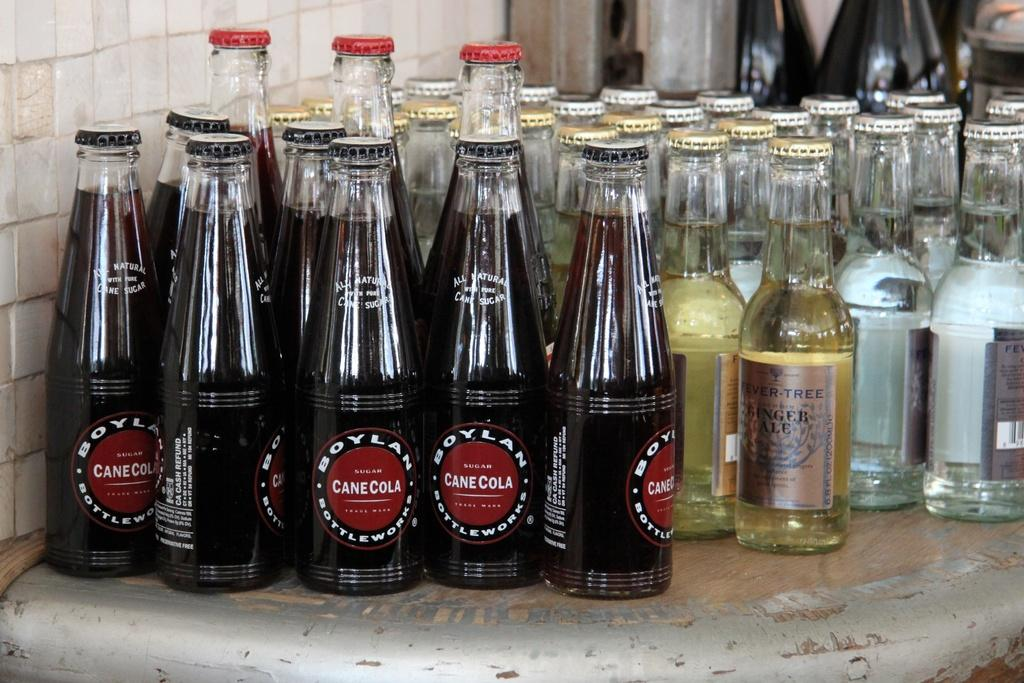What type of containers are holding the drink in the image? There are glass bottles with drink in the image. What is the color and material of the surface the bottles are on? The surface is brown and ash color, and it appears to be made of wood or a similar material. What can be seen on the left side of the image? There is a wall visible to the left in the image. What type of skirt is the representative wearing in the image? There is no representative or skirt present in the image; it only features glass bottles with drink on a brown and ash color surface. 